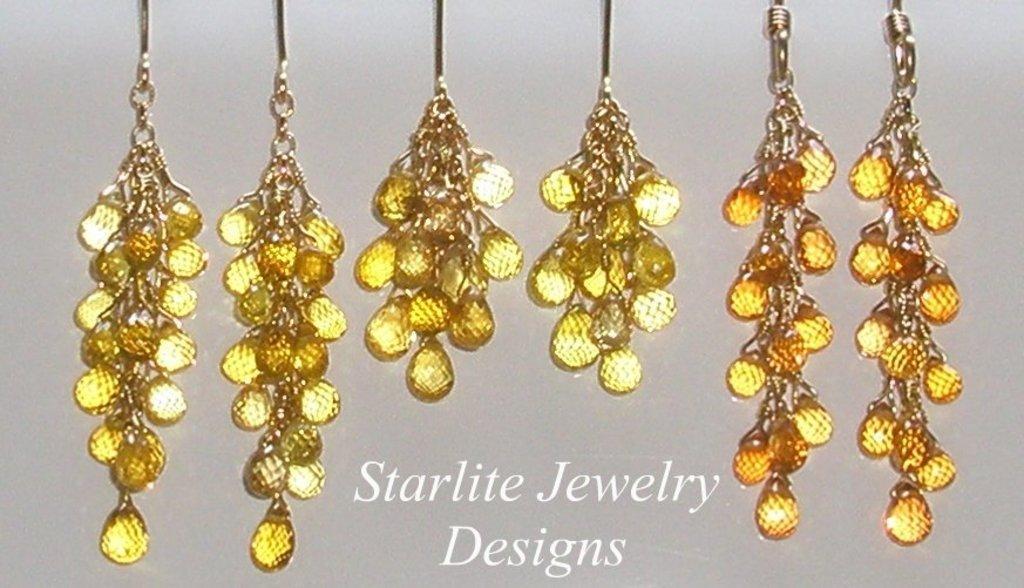Can you describe this image briefly? As we can see in the image there are decorative items and at the bottom there is something written. 